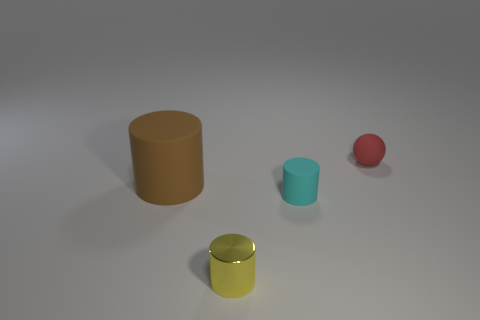Subtract 1 cylinders. How many cylinders are left? 2 Add 1 big matte objects. How many objects exist? 5 Subtract all cylinders. How many objects are left? 1 Add 1 small cyan cylinders. How many small cyan cylinders are left? 2 Add 2 red rubber balls. How many red rubber balls exist? 3 Subtract 0 cyan spheres. How many objects are left? 4 Subtract all large brown rubber cylinders. Subtract all big rubber cylinders. How many objects are left? 2 